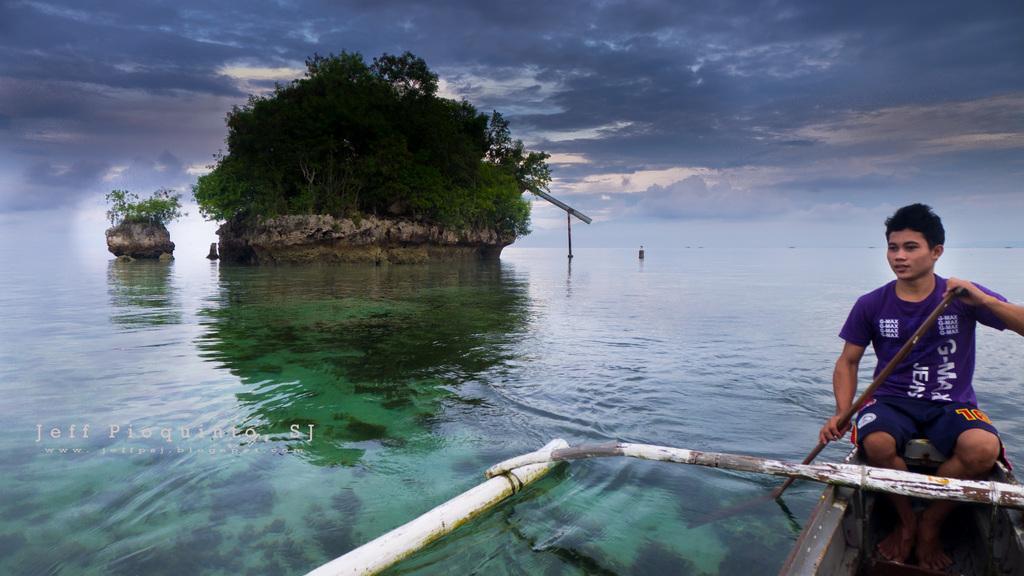Please provide a concise description of this image. In this picture we can see a man sitting in the boat, at the bottom there is water, we can see trees and a rock in the background, there is the sky at the top of the picture, this man is holding a paddle, on the left side there is some text. 